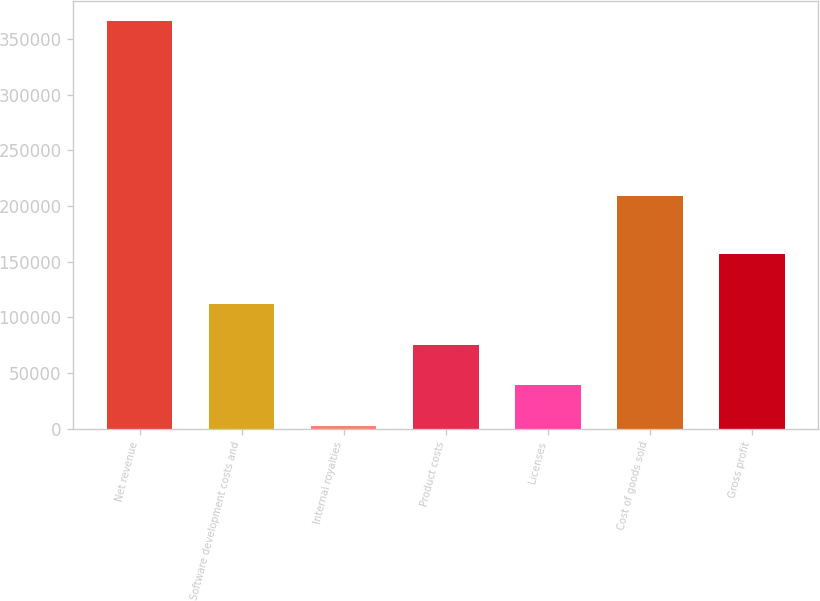Convert chart. <chart><loc_0><loc_0><loc_500><loc_500><bar_chart><fcel>Net revenue<fcel>Software development costs and<fcel>Internal royalties<fcel>Product costs<fcel>Licenses<fcel>Cost of goods sold<fcel>Gross profit<nl><fcel>366050<fcel>112163<fcel>2172<fcel>75430.8<fcel>39043<fcel>209086<fcel>156964<nl></chart> 